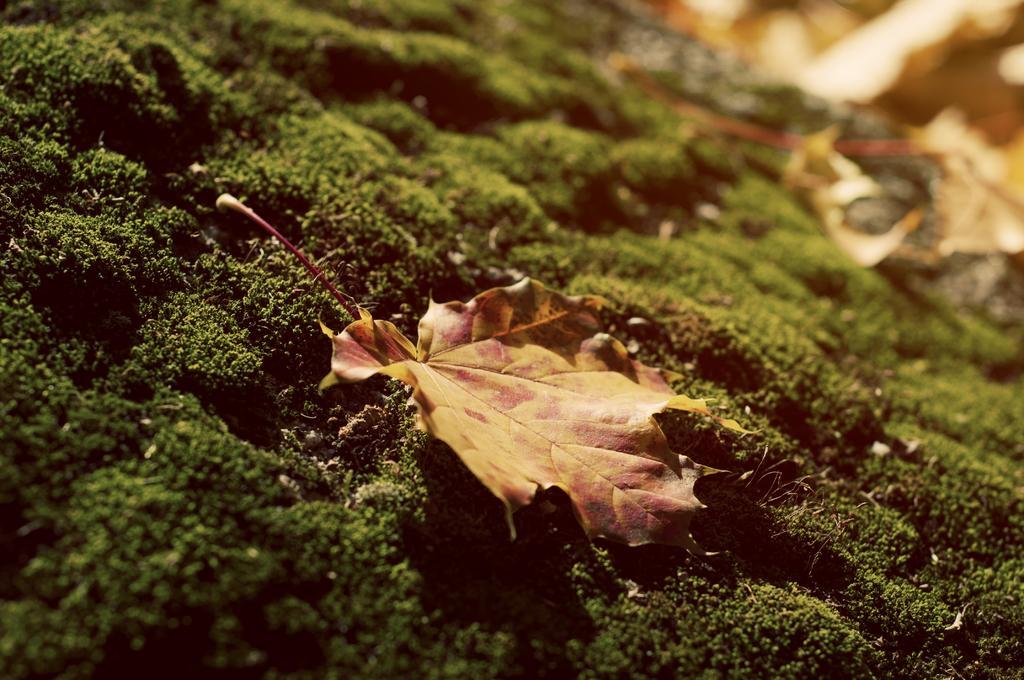Can you describe this image briefly? In this image I can see the grass and a leaf. In the background of the image it is blurry. 